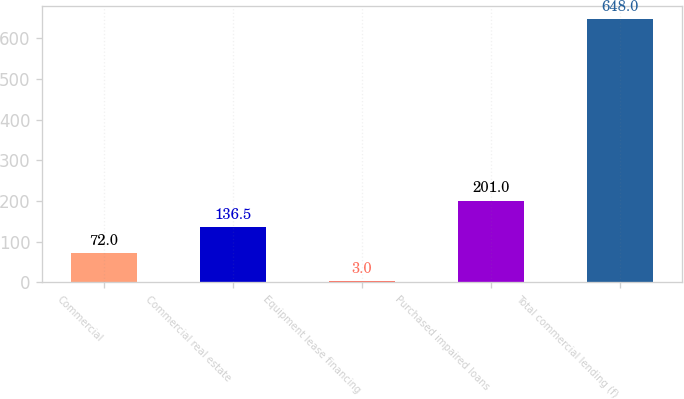Convert chart to OTSL. <chart><loc_0><loc_0><loc_500><loc_500><bar_chart><fcel>Commercial<fcel>Commercial real estate<fcel>Equipment lease financing<fcel>Purchased impaired loans<fcel>Total commercial lending (f)<nl><fcel>72<fcel>136.5<fcel>3<fcel>201<fcel>648<nl></chart> 